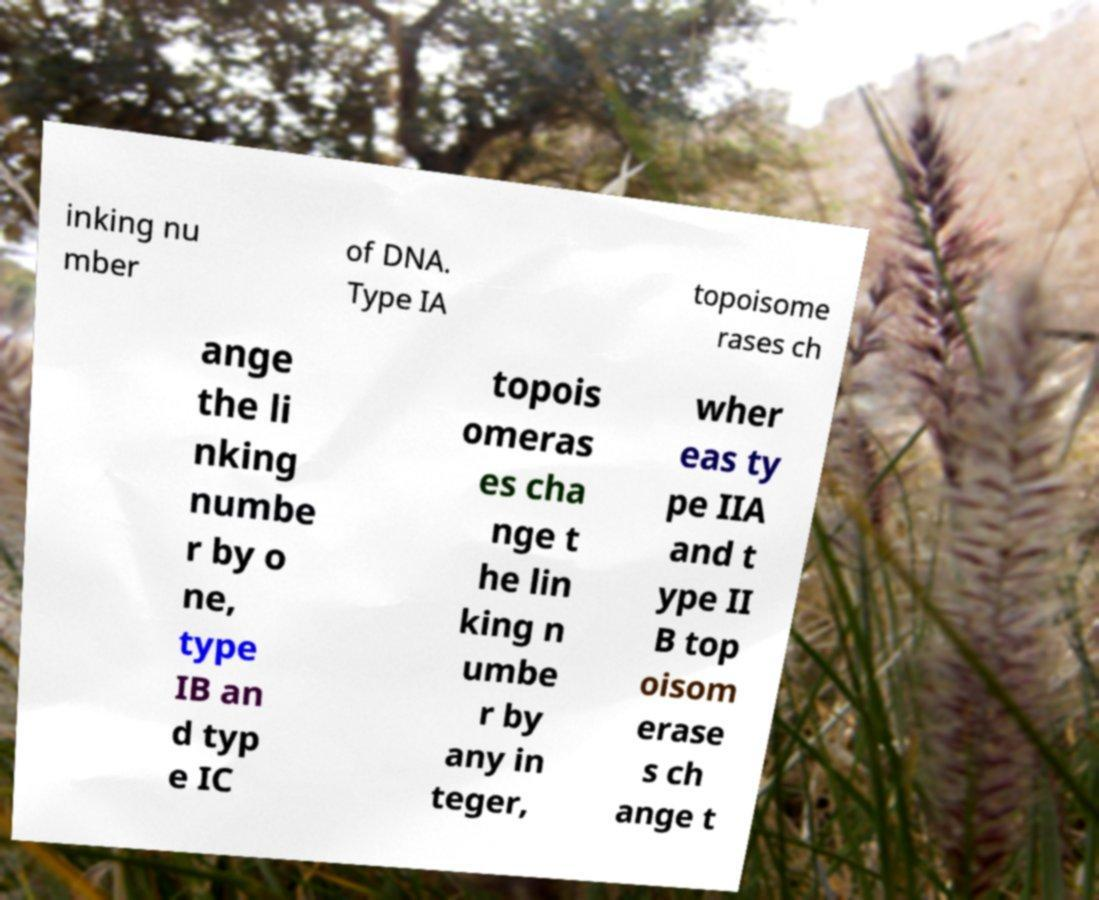I need the written content from this picture converted into text. Can you do that? inking nu mber of DNA. Type IA topoisome rases ch ange the li nking numbe r by o ne, type IB an d typ e IC topois omeras es cha nge t he lin king n umbe r by any in teger, wher eas ty pe IIA and t ype II B top oisom erase s ch ange t 